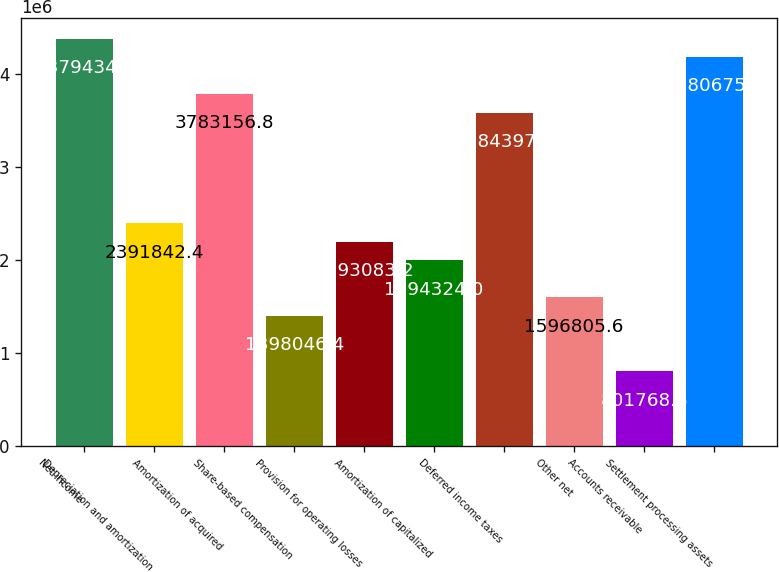Convert chart to OTSL. <chart><loc_0><loc_0><loc_500><loc_500><bar_chart><fcel>Net income<fcel>Depreciation and amortization<fcel>Amortization of acquired<fcel>Share-based compensation<fcel>Provision for operating losses<fcel>Amortization of capitalized<fcel>Deferred income taxes<fcel>Other net<fcel>Accounts receivable<fcel>Settlement processing assets<nl><fcel>4.37943e+06<fcel>2.39184e+06<fcel>3.78316e+06<fcel>1.39805e+06<fcel>2.19308e+06<fcel>1.99432e+06<fcel>3.5844e+06<fcel>1.59681e+06<fcel>801769<fcel>4.18068e+06<nl></chart> 